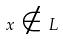Convert formula to latex. <formula><loc_0><loc_0><loc_500><loc_500>x \notin L</formula> 